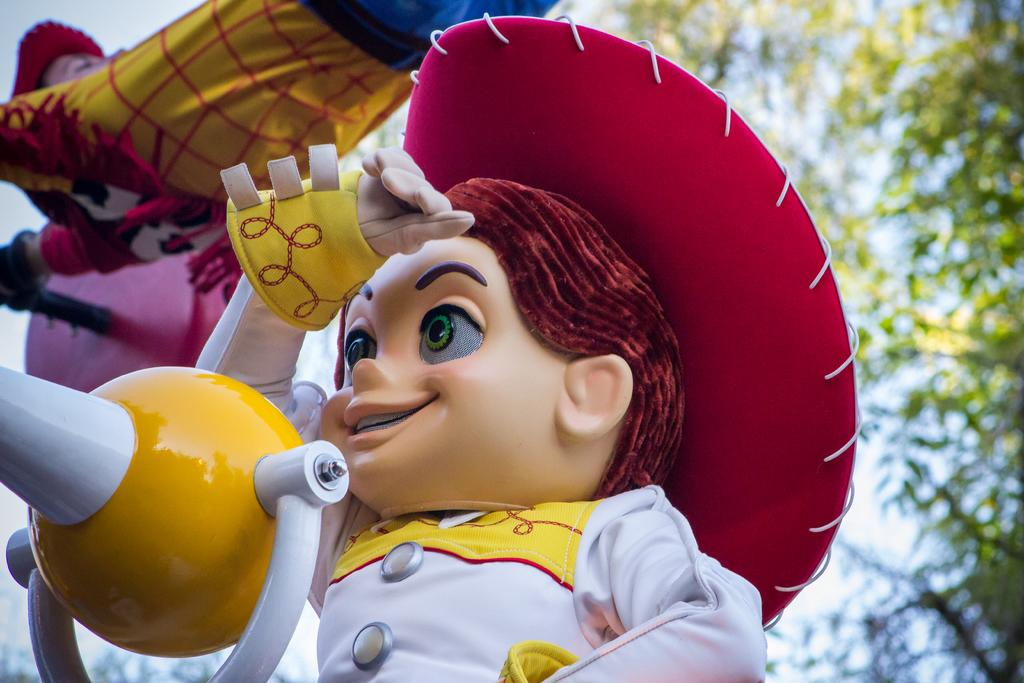What objects can be seen in the image? There are toys in the image. What type of vegetation is on the right side of the image? There are trees on the right side of the image. What type of knife is being used to cut the tree in the image? There is no knife or tree-cutting activity present in the image. 